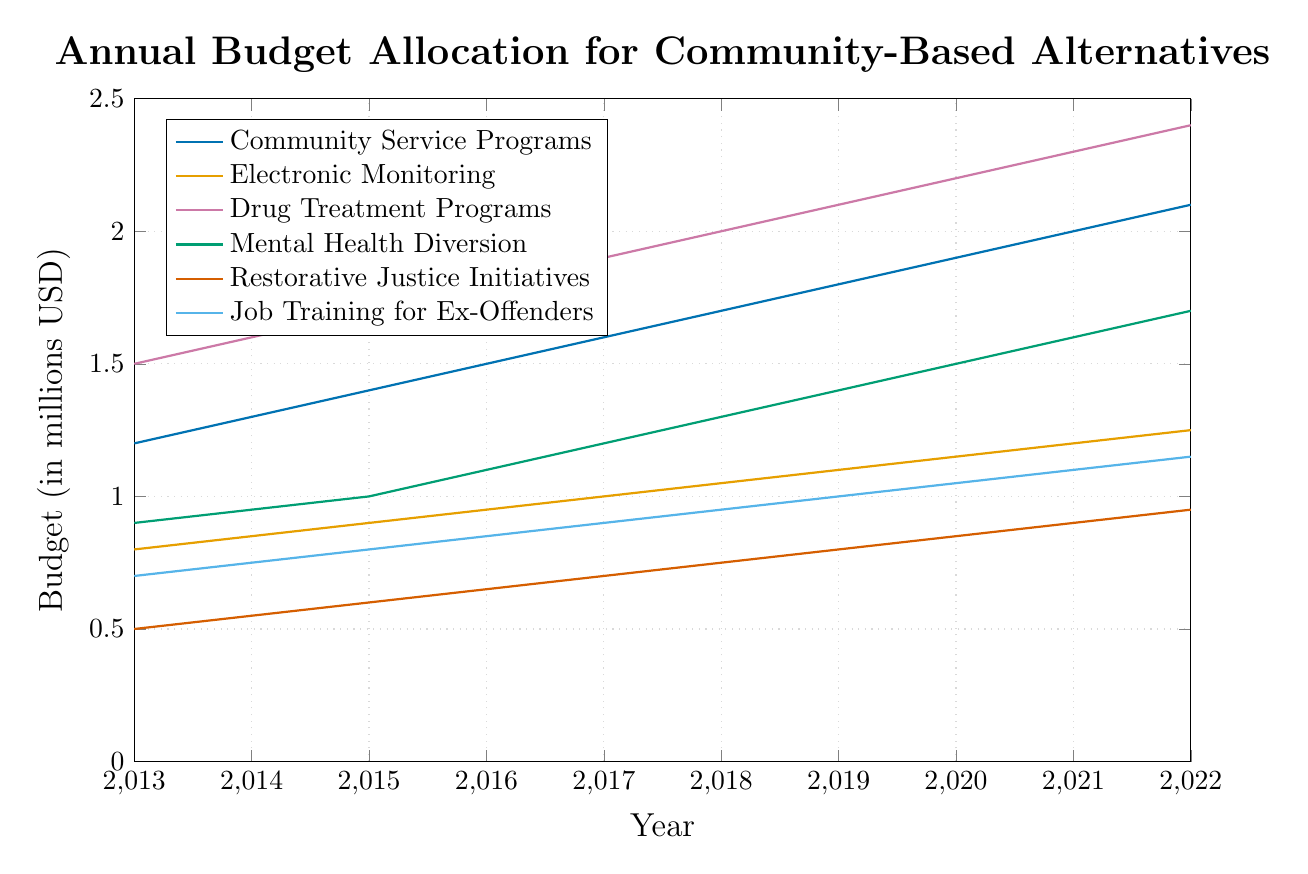What trend can you observe in the budget allocation for Community Service Programs over the past decade? The budget allocation for Community Service Programs has increased steadily from 1.2 million USD in 2013 to 2.1 million USD in 2022. The increase is consistent each year, indicating a growing emphasis on this program.
Answer: Increasing trend Which program had the highest budget allocation in 2022? In 2022, the highest budget allocation was for Drug Treatment Programs, with 2.4 million USD.
Answer: Drug Treatment Programs By how much did the budget for Mental Health Diversion increase from 2013 to 2022? The budget for Mental Health Diversion in 2013 was 0.9 million USD, and it increased to 1.7 million USD in 2022. The difference is 1.7 - 0.9 = 0.8 million USD.
Answer: 0.8 million USD Which two programs had the largest difference in their budgets in 2018? In 2018, Drug Treatment Programs had the highest budget of 2.0 million USD, while Restorative Justice Initiatives had the lowest budget of 0.75 million USD. The difference is 2.0 - 0.75 = 1.25 million USD.
Answer: Drug Treatment Programs and Restorative Justice Initiatives In which year did the Electronic Monitoring budget first surpass 1 million USD? The budget for Electronic Monitoring first reached 1 million USD in 2017.
Answer: 2017 What is the average budget for Restorative Justice Initiatives from 2013 to 2022? Over these 10 years, the years' budgets are: 0.5, 0.55, 0.6, 0.65, 0.7, 0.75, 0.8, 0.85, 0.9, 0.95 million USD. Total = 7.15 million USD. Average = 7.15/10 = 0.715 million USD.
Answer: 0.715 million USD Which program showed the most stable annual increase in budget allocation? Community Service Programs show the most stable annual increase, with a consistent increase of 0.1 million USD every year from 2013 to 2022.
Answer: Community Service Programs Compare the budget growth rate of Drug Treatment Programs and Job Training for Ex-Offenders from 2013 to 2022. Drug Treatment Programs increased from 1.5 million USD to 2.4 million USD: growth = (2.4-1.5)/1.5 = 60%. Job Training for Ex-Offenders increased from 0.7 million USD to 1.15 million USD: growth = (1.15-0.7)/0.7 = 64.3%.
Answer: Job Training for Ex-Offenders grew faster By what percentage did the budget for Job Training for Ex-Offenders increase from 2013 to 2022? The budget for Job Training for Ex-Offenders increased from 0.7 million USD in 2013 to 1.15 million USD in 2022. Percentage increase = (1.15 - 0.7) / 0.7 * 100% = 64.3%
Answer: 64.3% 